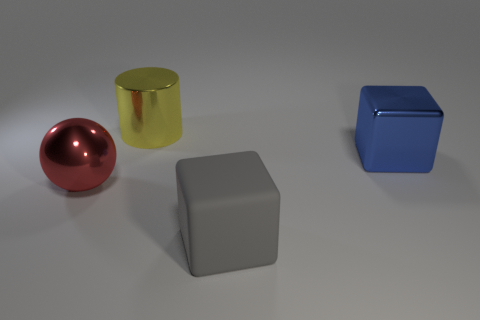Does the yellow shiny thing that is left of the gray cube have the same shape as the red object?
Give a very brief answer. No. Is the number of objects that are behind the shiny ball greater than the number of gray things?
Your response must be concise. Yes. How many objects are on the left side of the blue cube and behind the large sphere?
Your response must be concise. 1. What is the color of the thing left of the object that is behind the blue cube?
Your answer should be compact. Red. Are there fewer metallic blocks than metallic objects?
Make the answer very short. Yes. Are there more large yellow cylinders that are to the left of the large rubber object than red shiny balls that are to the right of the big shiny block?
Keep it short and to the point. Yes. Is the cylinder made of the same material as the large ball?
Your answer should be very brief. Yes. What number of gray matte things are to the left of the large metal object that is left of the cylinder?
Offer a very short reply. 0. What number of objects are big brown balls or big things behind the big gray cube?
Offer a very short reply. 3. Do the metallic object right of the large yellow metal thing and the gray thing that is in front of the big metallic cube have the same shape?
Your response must be concise. Yes. 